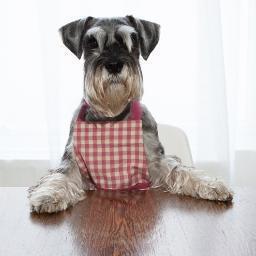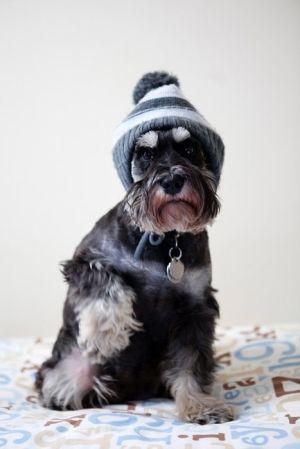The first image is the image on the left, the second image is the image on the right. Evaluate the accuracy of this statement regarding the images: "in the right pic the dog is wearing something". Is it true? Answer yes or no. Yes. The first image is the image on the left, the second image is the image on the right. Examine the images to the left and right. Is the description "There are at least 3 dogs and 2 are sitting in these." accurate? Answer yes or no. No. 